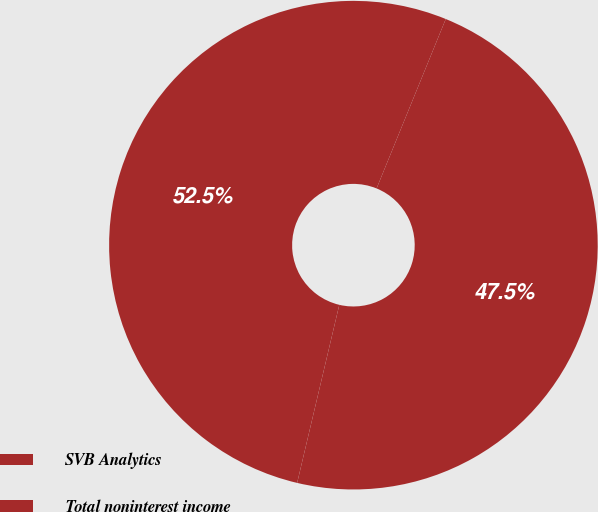Convert chart. <chart><loc_0><loc_0><loc_500><loc_500><pie_chart><fcel>SVB Analytics<fcel>Total noninterest income<nl><fcel>52.47%<fcel>47.53%<nl></chart> 